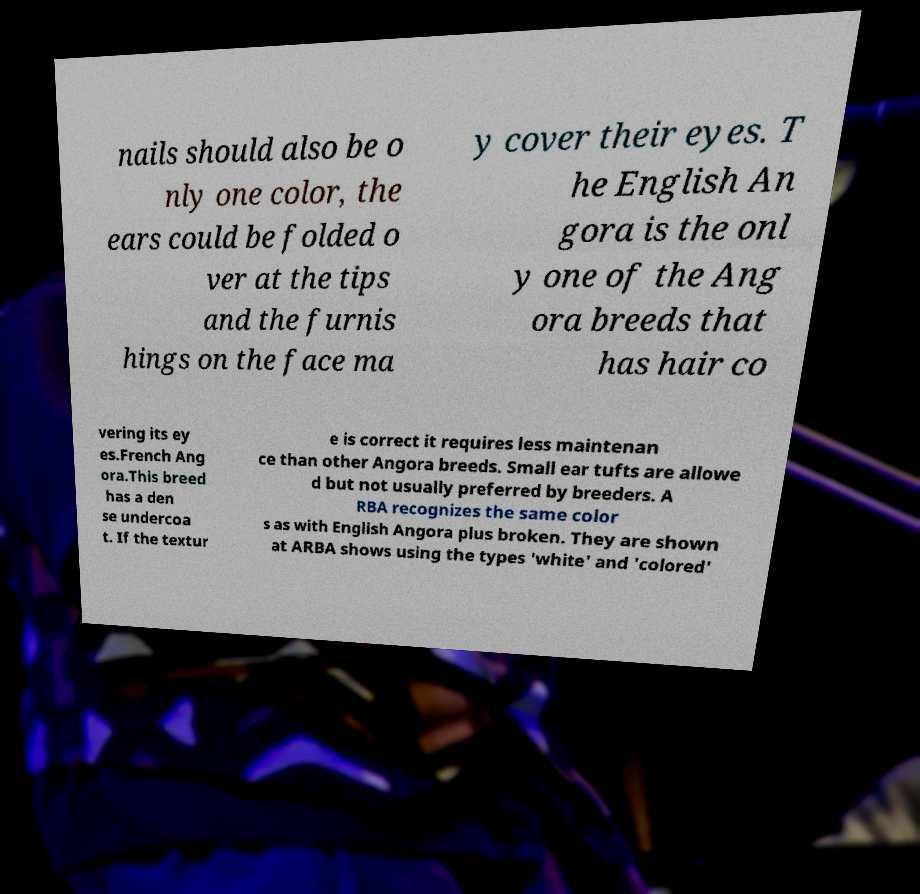Could you assist in decoding the text presented in this image and type it out clearly? nails should also be o nly one color, the ears could be folded o ver at the tips and the furnis hings on the face ma y cover their eyes. T he English An gora is the onl y one of the Ang ora breeds that has hair co vering its ey es.French Ang ora.This breed has a den se undercoa t. If the textur e is correct it requires less maintenan ce than other Angora breeds. Small ear tufts are allowe d but not usually preferred by breeders. A RBA recognizes the same color s as with English Angora plus broken. They are shown at ARBA shows using the types 'white' and 'colored' 